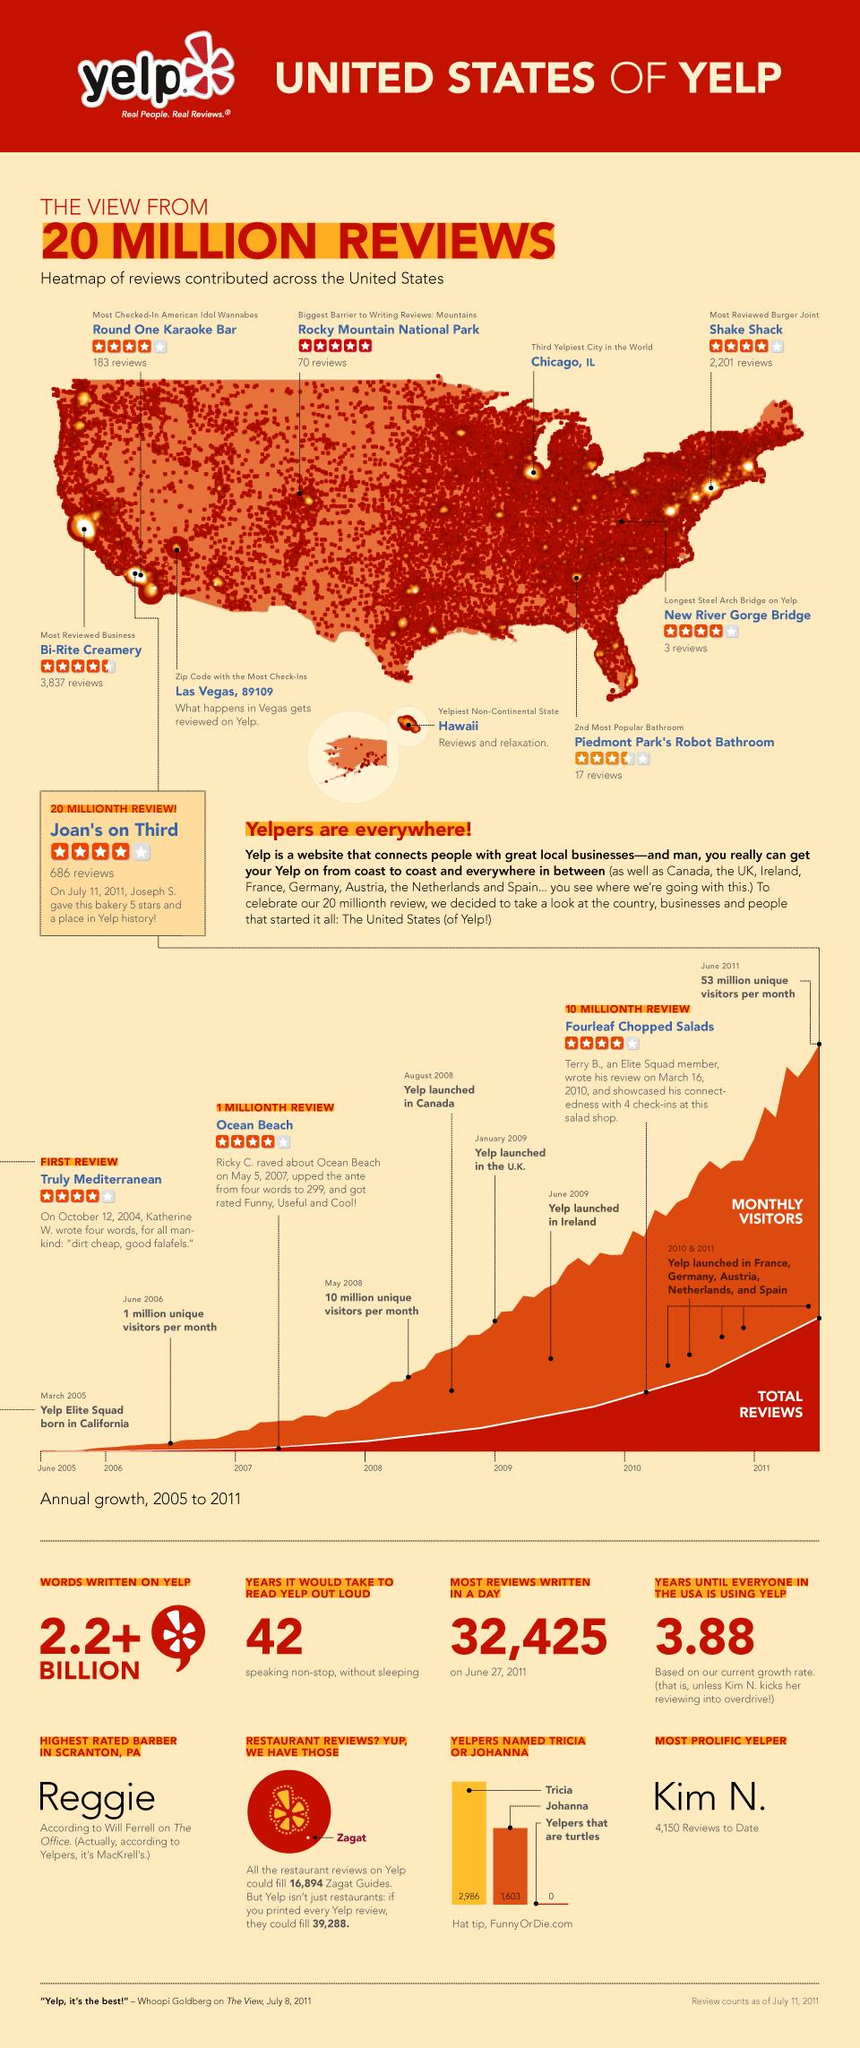Mention a couple of crucial points in this snapshot. The zip code that has seen the highest number of check-ins on Yelp in the United States is 89109, which is located in Las Vegas. On any given day, Yelp users have written a staggering 32,425 reviews. There are 2,201 reviews available for 'Shake Shack' Burger joint on Yelp. Bi-Rite Creamery is the most reviewed business in the United States on Yelp, with many positive reviews from satisfied customers. Kim N. is the most prolific yelper with 4,150 reviews to date. 